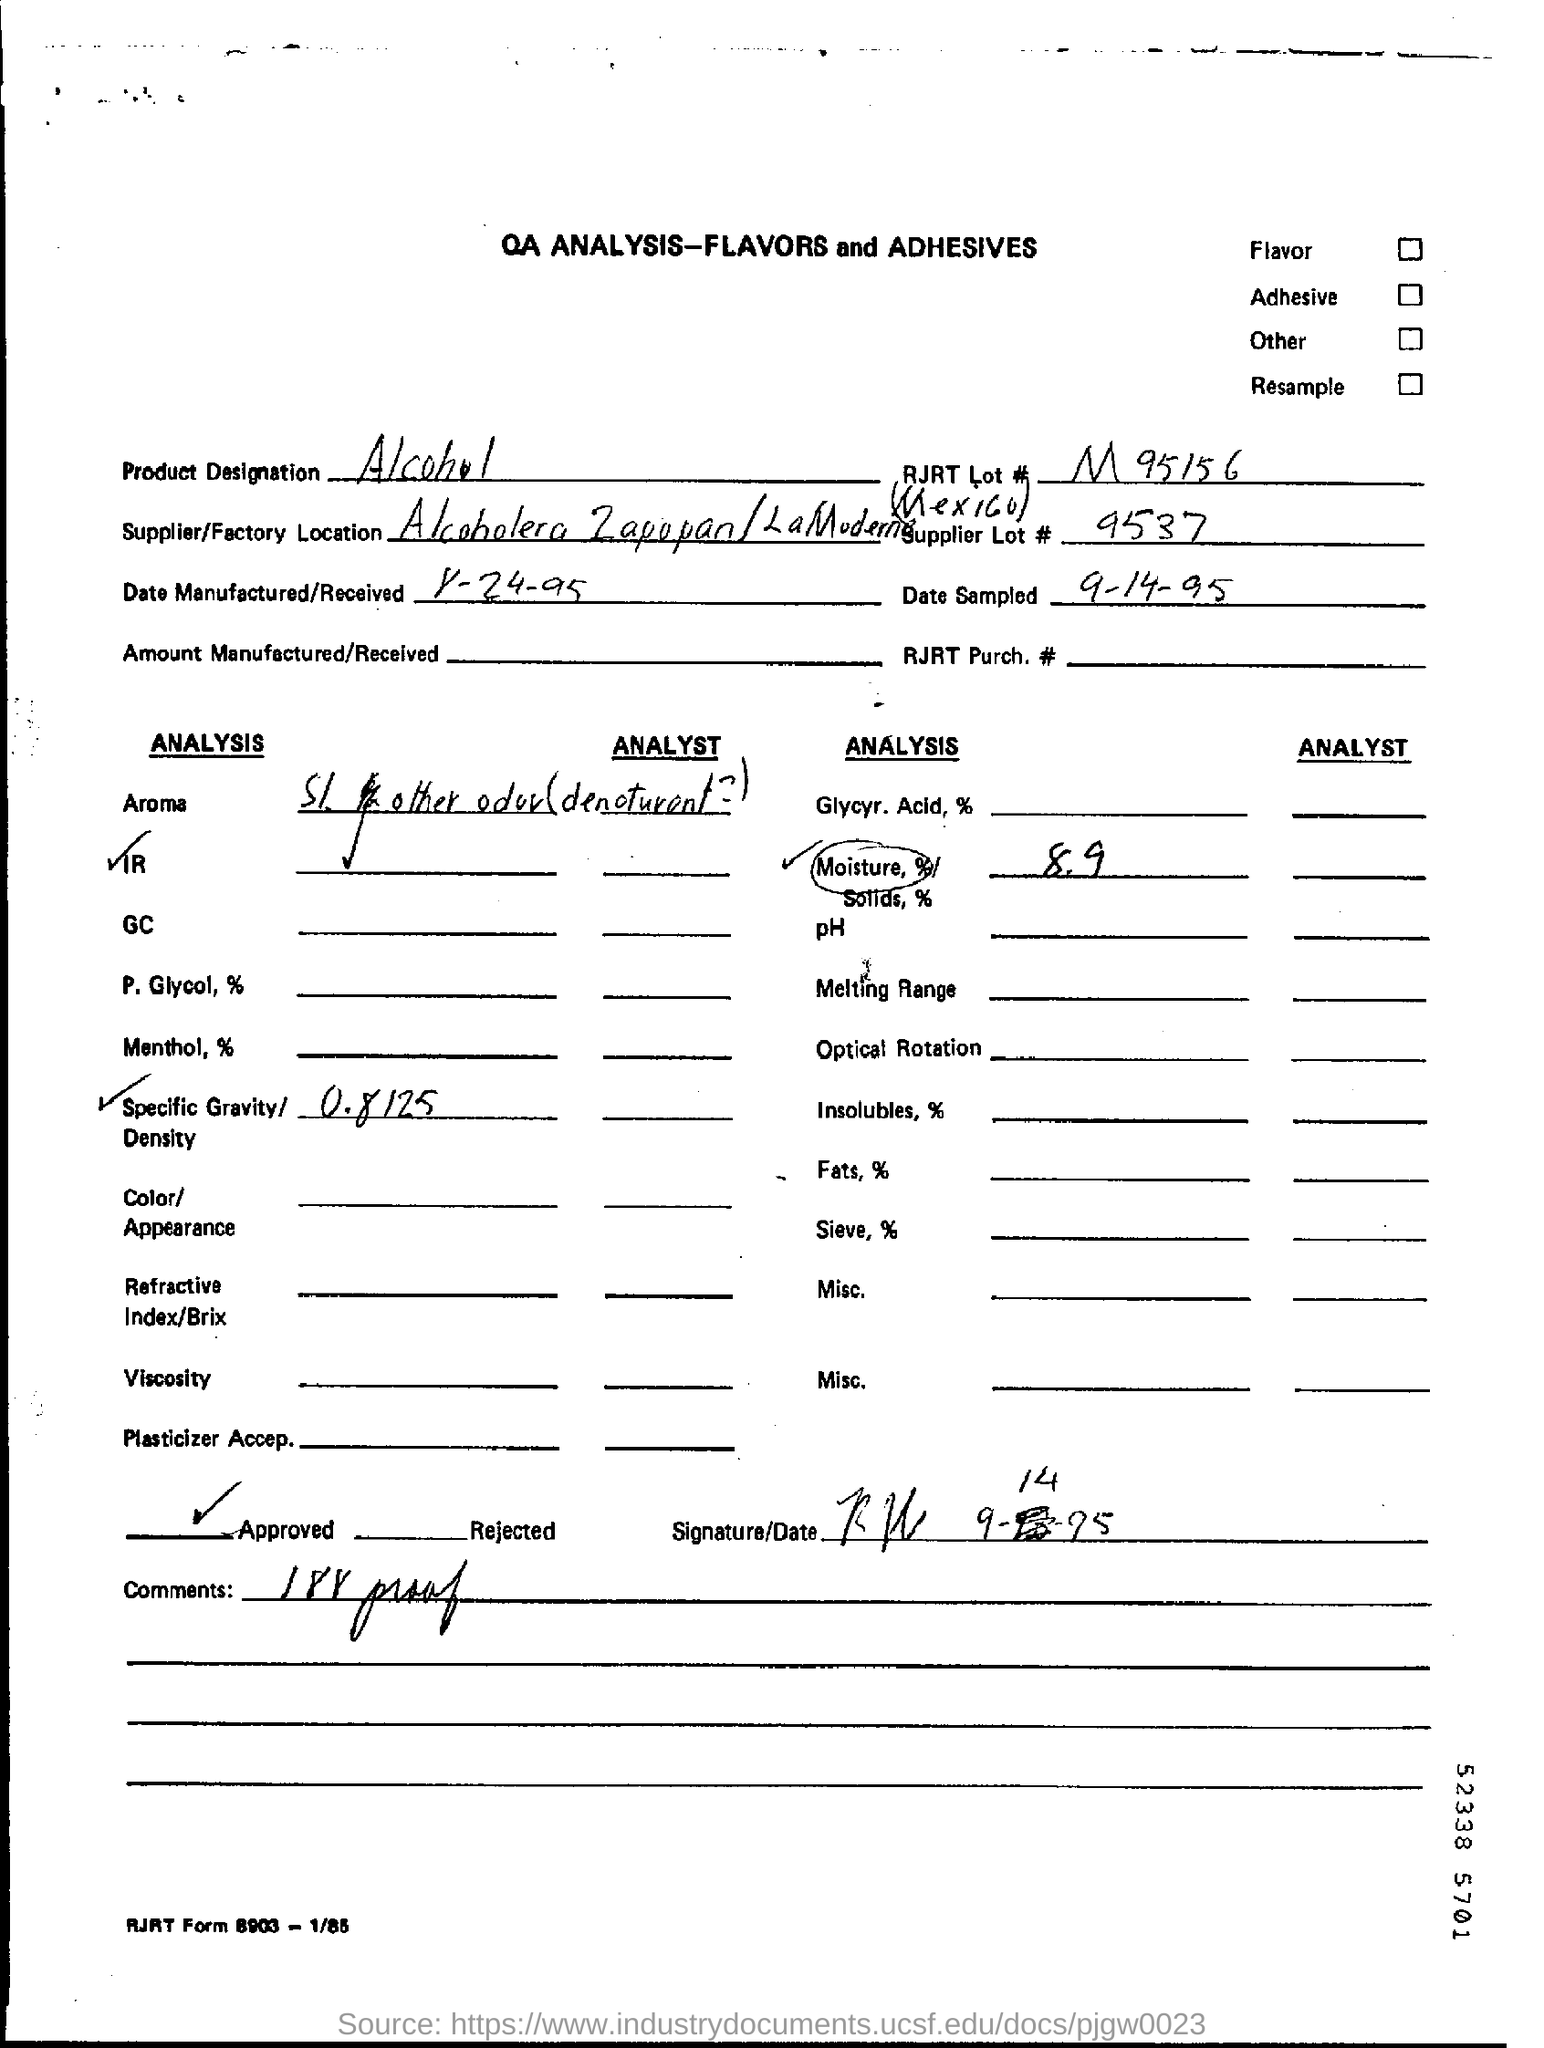What is the product designation ?
Offer a terse response. Alcohol. What is the moisture percentage ?
Provide a short and direct response. 8.9. What is the supplier lot number ?
Make the answer very short. 9537. 